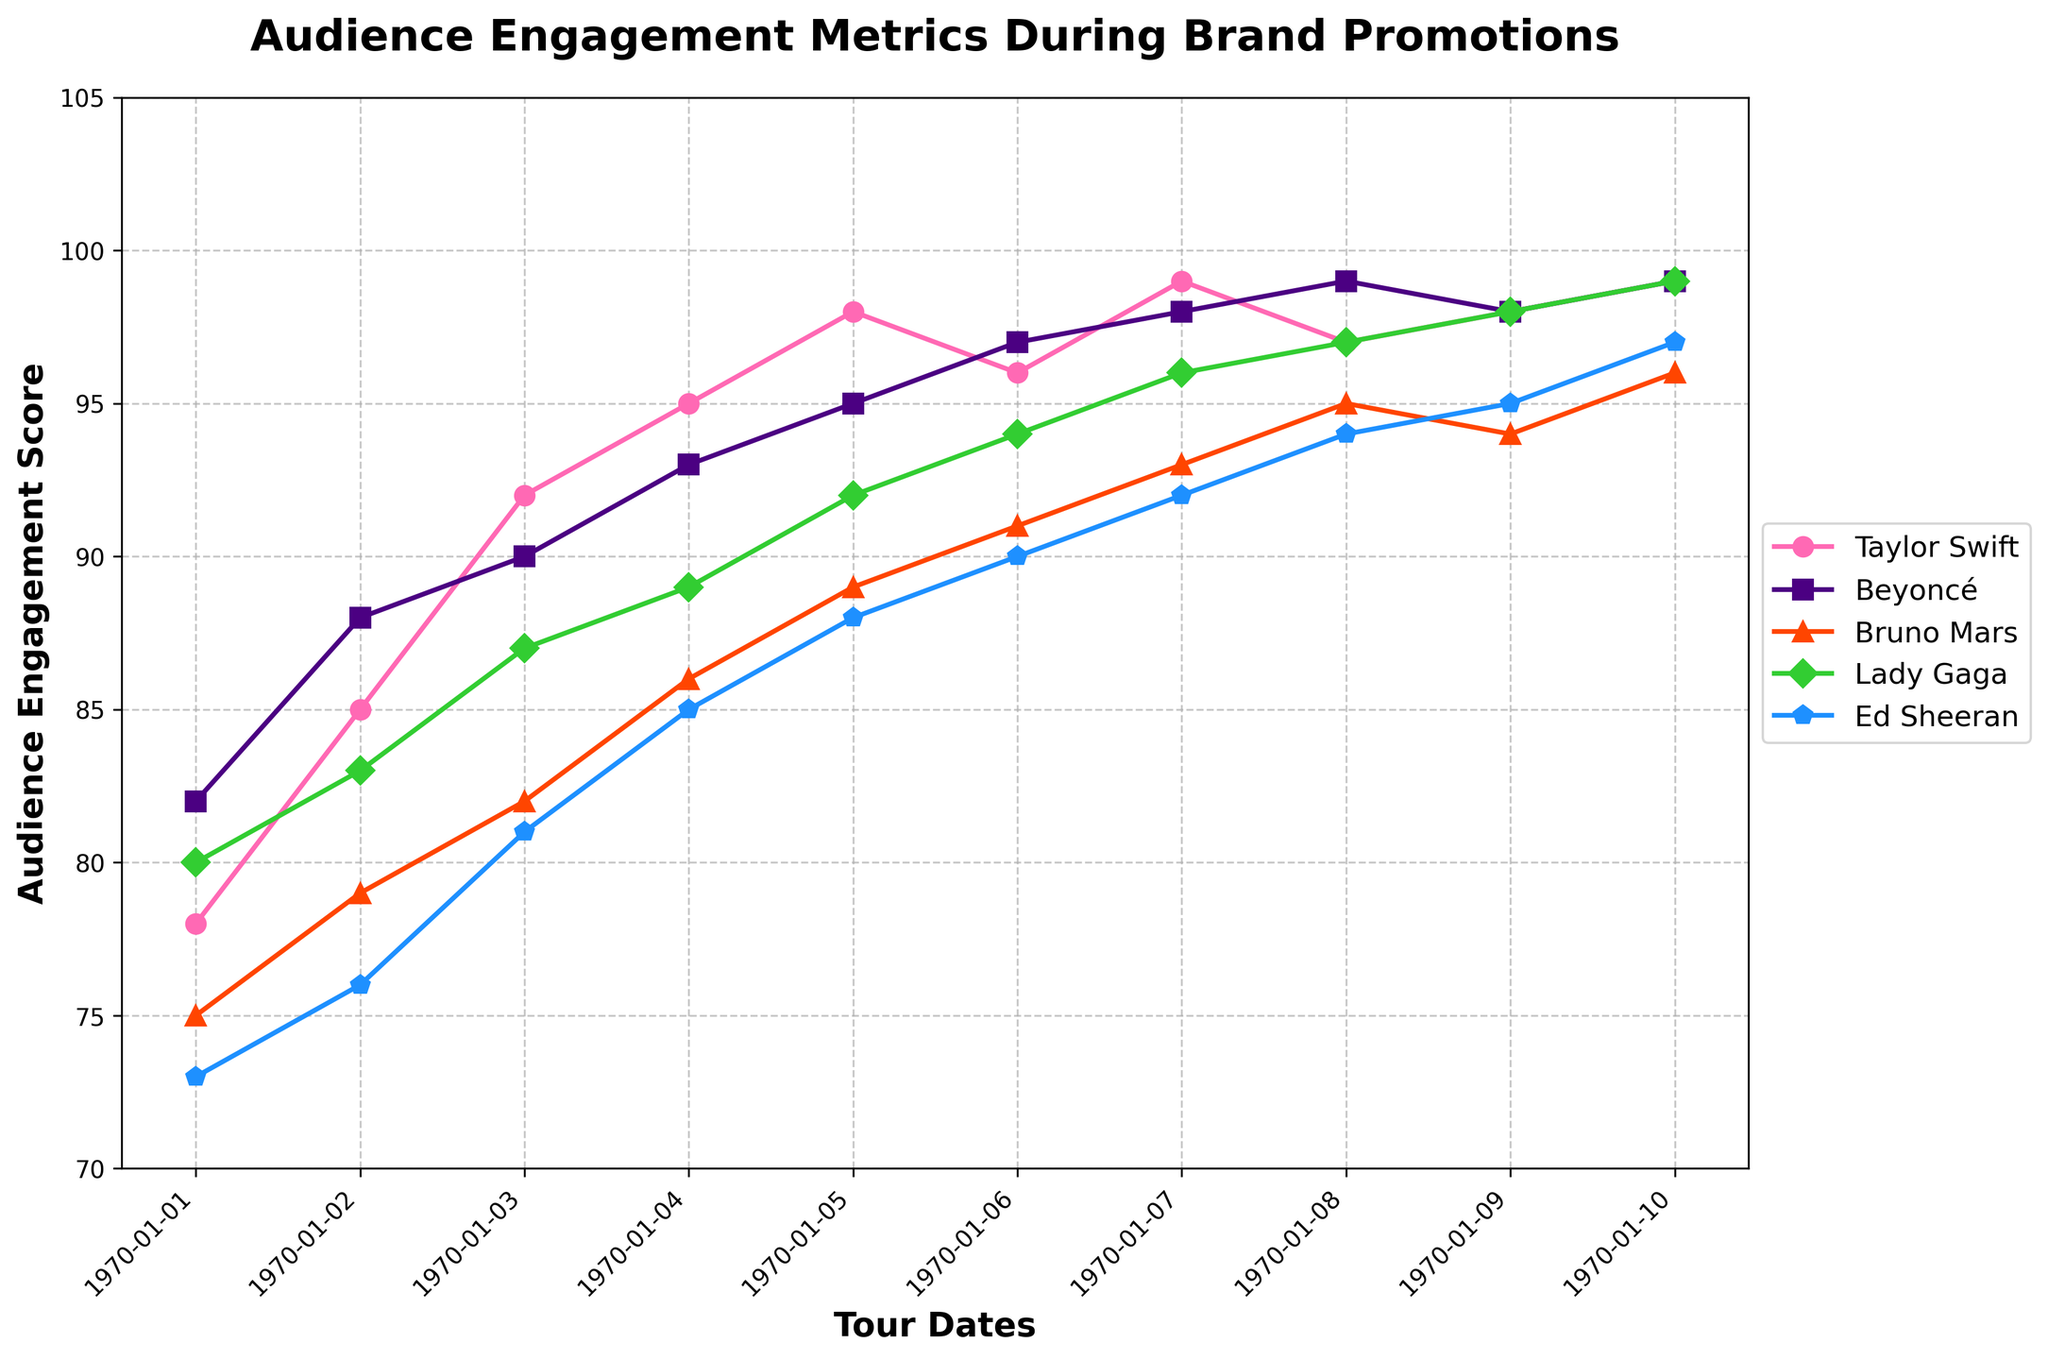Which artist had the highest audience engagement on 2023-05-26? Check the engagement scores for 2023-05-26. Beyoncé has the highest score of 95.
Answer: Beyoncé What is the difference between Taylor Swift’s and Ed Sheeran’s engagement scores on 2023-07-01? Taylor Swift's score is 99 and Ed Sheeran's score is 92 on 2023-07-01. The difference is 99 - 92 = 7.
Answer: 7 On which date did Lady Gaga’s audience engagement surpass 90 for the first time? Check Lady Gaga's engagement scores in chronological order. The score first surpasses 90 on 2023-05-08 with a score of 89.
Answer: 2023-05-08 Compare the engagement trends for Taylor Swift and Bruno Mars. Did Bruno Mars ever surpass Taylor Swift's engagement? Examine the plot lines for both artists. Bruno Mars never surpasses Taylor Swift's engagement scores on any date.
Answer: No Which artist had the most consistent engagement scores from 2023-07-01 to 2023-08-24? Evaluate the variation in engagement scores between 2023-07-01 and 2023-08-24 for all artists. Taylor Swift’s scores show the least fluctuation (99 to 97).
Answer: Taylor Swift Calculate the average audience engagement score for Beyoncé throughout the tour dates. Sum Beyoncé’s scores (82 + 88 + 90 + 93 + 95 + 97 + 98 + 99 + 98 + 99) = 939 and divide by 10. The average is 939/10 = 93.9.
Answer: 93.9 Which artist showed the greatest increase in engagement from 2023-03-15 to 2023-08-24? Calculate the difference between engagement scores on 2023-03-15 and 2023-08-24 for all artists. Taylor Swift: 21, Beyoncé: 17, Bruno Mars: 21, Lady Gaga: 19, Ed Sheeran: 24. Ed Sheeran has the greatest increase (24).
Answer: Ed Sheeran What visual color represents the data for Lady Gaga? Check the plot and identify the color used for Lady Gaga's line. Lady Gaga is represented by the green color.
Answer: Green What is the average engagement score for all artists on 2023-04-02? Sum the scores of all artists on 2023-04-02 (85 + 88 + 79 + 83 + 76) = 411 and divide by 5. The average score is 411/5 = 82.2.
Answer: 82.2 